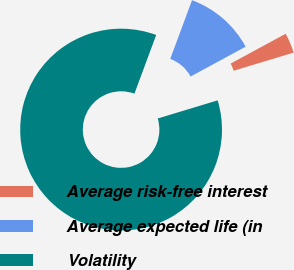Convert chart to OTSL. <chart><loc_0><loc_0><loc_500><loc_500><pie_chart><fcel>Average risk-free interest<fcel>Average expected life (in<fcel>Volatility<nl><fcel>3.23%<fcel>11.44%<fcel>85.32%<nl></chart> 